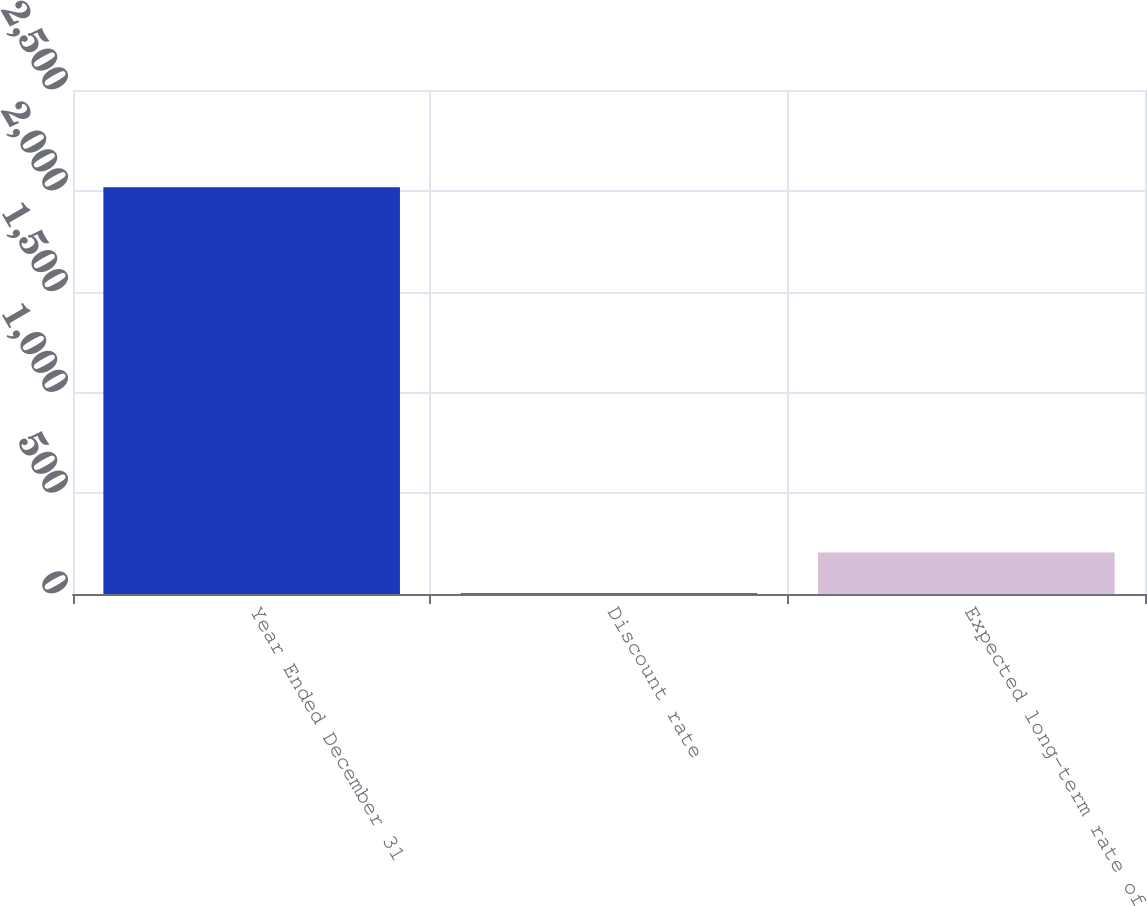Convert chart to OTSL. <chart><loc_0><loc_0><loc_500><loc_500><bar_chart><fcel>Year Ended December 31<fcel>Discount rate<fcel>Expected long-term rate of<nl><fcel>2017<fcel>4<fcel>205.3<nl></chart> 